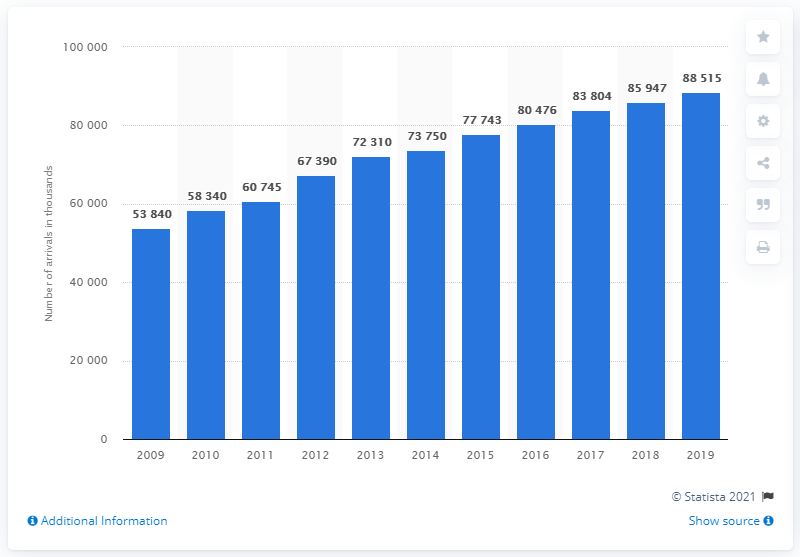Identify some key points in this picture. The number of international visitors to Poland increased between the year 2009 and the present day. 